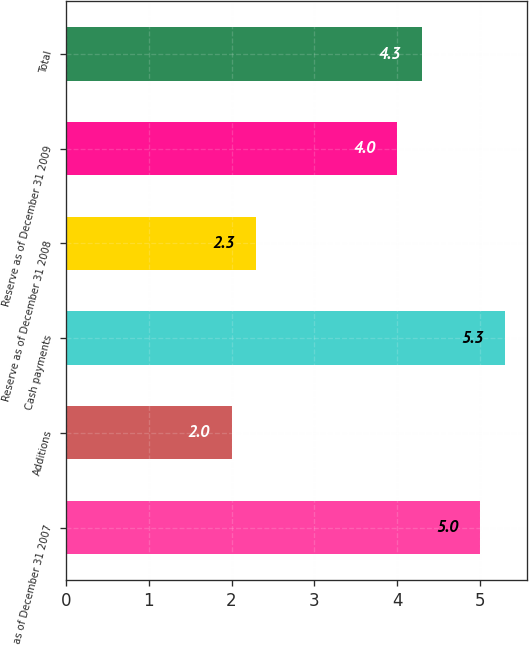Convert chart. <chart><loc_0><loc_0><loc_500><loc_500><bar_chart><fcel>Reserve as of December 31 2007<fcel>Additions<fcel>Cash payments<fcel>Reserve as of December 31 2008<fcel>Reserve as of December 31 2009<fcel>Total<nl><fcel>5<fcel>2<fcel>5.3<fcel>2.3<fcel>4<fcel>4.3<nl></chart> 